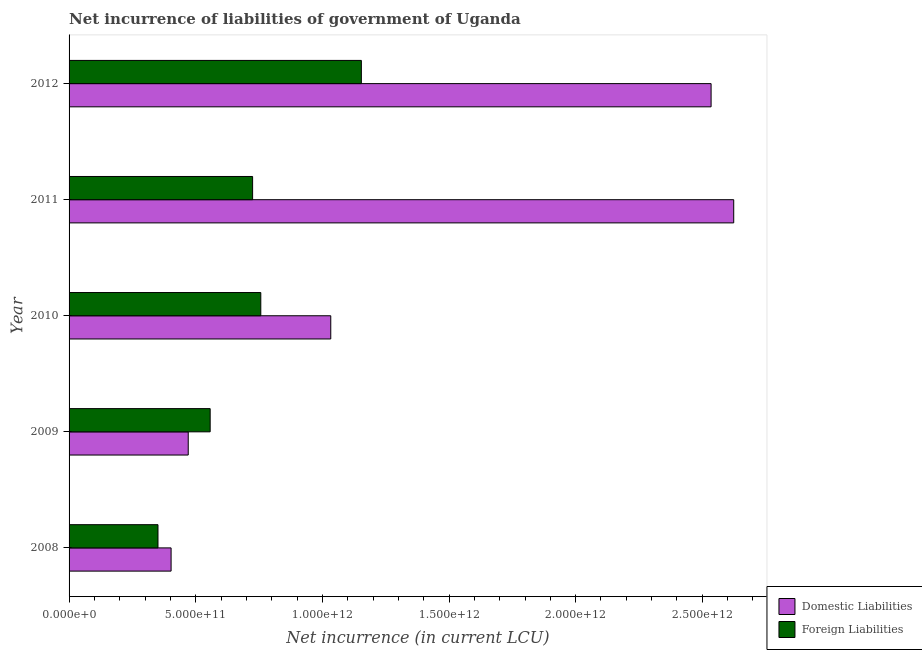How many groups of bars are there?
Offer a very short reply. 5. How many bars are there on the 5th tick from the bottom?
Offer a terse response. 2. What is the net incurrence of foreign liabilities in 2008?
Give a very brief answer. 3.51e+11. Across all years, what is the maximum net incurrence of foreign liabilities?
Your response must be concise. 1.15e+12. Across all years, what is the minimum net incurrence of domestic liabilities?
Provide a short and direct response. 4.03e+11. What is the total net incurrence of domestic liabilities in the graph?
Offer a very short reply. 7.07e+12. What is the difference between the net incurrence of domestic liabilities in 2009 and that in 2012?
Make the answer very short. -2.06e+12. What is the difference between the net incurrence of domestic liabilities in 2009 and the net incurrence of foreign liabilities in 2011?
Provide a succinct answer. -2.54e+11. What is the average net incurrence of foreign liabilities per year?
Your response must be concise. 7.09e+11. In the year 2012, what is the difference between the net incurrence of domestic liabilities and net incurrence of foreign liabilities?
Offer a very short reply. 1.38e+12. In how many years, is the net incurrence of foreign liabilities greater than 900000000000 LCU?
Your response must be concise. 1. What is the ratio of the net incurrence of foreign liabilities in 2011 to that in 2012?
Offer a terse response. 0.63. Is the difference between the net incurrence of domestic liabilities in 2008 and 2012 greater than the difference between the net incurrence of foreign liabilities in 2008 and 2012?
Ensure brevity in your answer.  No. What is the difference between the highest and the second highest net incurrence of foreign liabilities?
Ensure brevity in your answer.  3.97e+11. What is the difference between the highest and the lowest net incurrence of foreign liabilities?
Your answer should be compact. 8.03e+11. Is the sum of the net incurrence of domestic liabilities in 2009 and 2010 greater than the maximum net incurrence of foreign liabilities across all years?
Provide a short and direct response. Yes. What does the 2nd bar from the top in 2011 represents?
Ensure brevity in your answer.  Domestic Liabilities. What does the 1st bar from the bottom in 2011 represents?
Offer a very short reply. Domestic Liabilities. How many bars are there?
Your response must be concise. 10. What is the difference between two consecutive major ticks on the X-axis?
Give a very brief answer. 5.00e+11. Are the values on the major ticks of X-axis written in scientific E-notation?
Give a very brief answer. Yes. Does the graph contain any zero values?
Offer a terse response. No. Where does the legend appear in the graph?
Your response must be concise. Bottom right. What is the title of the graph?
Make the answer very short. Net incurrence of liabilities of government of Uganda. What is the label or title of the X-axis?
Your answer should be very brief. Net incurrence (in current LCU). What is the label or title of the Y-axis?
Provide a succinct answer. Year. What is the Net incurrence (in current LCU) in Domestic Liabilities in 2008?
Offer a terse response. 4.03e+11. What is the Net incurrence (in current LCU) in Foreign Liabilities in 2008?
Your response must be concise. 3.51e+11. What is the Net incurrence (in current LCU) of Domestic Liabilities in 2009?
Your response must be concise. 4.70e+11. What is the Net incurrence (in current LCU) in Foreign Liabilities in 2009?
Offer a very short reply. 5.57e+11. What is the Net incurrence (in current LCU) in Domestic Liabilities in 2010?
Offer a very short reply. 1.03e+12. What is the Net incurrence (in current LCU) of Foreign Liabilities in 2010?
Provide a succinct answer. 7.57e+11. What is the Net incurrence (in current LCU) in Domestic Liabilities in 2011?
Your response must be concise. 2.62e+12. What is the Net incurrence (in current LCU) in Foreign Liabilities in 2011?
Give a very brief answer. 7.25e+11. What is the Net incurrence (in current LCU) of Domestic Liabilities in 2012?
Keep it short and to the point. 2.53e+12. What is the Net incurrence (in current LCU) in Foreign Liabilities in 2012?
Make the answer very short. 1.15e+12. Across all years, what is the maximum Net incurrence (in current LCU) in Domestic Liabilities?
Your answer should be very brief. 2.62e+12. Across all years, what is the maximum Net incurrence (in current LCU) in Foreign Liabilities?
Your answer should be compact. 1.15e+12. Across all years, what is the minimum Net incurrence (in current LCU) of Domestic Liabilities?
Your answer should be compact. 4.03e+11. Across all years, what is the minimum Net incurrence (in current LCU) in Foreign Liabilities?
Provide a short and direct response. 3.51e+11. What is the total Net incurrence (in current LCU) of Domestic Liabilities in the graph?
Make the answer very short. 7.07e+12. What is the total Net incurrence (in current LCU) of Foreign Liabilities in the graph?
Offer a terse response. 3.54e+12. What is the difference between the Net incurrence (in current LCU) of Domestic Liabilities in 2008 and that in 2009?
Keep it short and to the point. -6.77e+1. What is the difference between the Net incurrence (in current LCU) in Foreign Liabilities in 2008 and that in 2009?
Offer a very short reply. -2.06e+11. What is the difference between the Net incurrence (in current LCU) in Domestic Liabilities in 2008 and that in 2010?
Provide a short and direct response. -6.30e+11. What is the difference between the Net incurrence (in current LCU) in Foreign Liabilities in 2008 and that in 2010?
Provide a short and direct response. -4.06e+11. What is the difference between the Net incurrence (in current LCU) in Domestic Liabilities in 2008 and that in 2011?
Provide a short and direct response. -2.22e+12. What is the difference between the Net incurrence (in current LCU) in Foreign Liabilities in 2008 and that in 2011?
Ensure brevity in your answer.  -3.74e+11. What is the difference between the Net incurrence (in current LCU) in Domestic Liabilities in 2008 and that in 2012?
Provide a short and direct response. -2.13e+12. What is the difference between the Net incurrence (in current LCU) of Foreign Liabilities in 2008 and that in 2012?
Keep it short and to the point. -8.03e+11. What is the difference between the Net incurrence (in current LCU) in Domestic Liabilities in 2009 and that in 2010?
Your response must be concise. -5.63e+11. What is the difference between the Net incurrence (in current LCU) of Foreign Liabilities in 2009 and that in 2010?
Ensure brevity in your answer.  -2.00e+11. What is the difference between the Net incurrence (in current LCU) in Domestic Liabilities in 2009 and that in 2011?
Provide a succinct answer. -2.15e+12. What is the difference between the Net incurrence (in current LCU) of Foreign Liabilities in 2009 and that in 2011?
Offer a terse response. -1.68e+11. What is the difference between the Net incurrence (in current LCU) in Domestic Liabilities in 2009 and that in 2012?
Ensure brevity in your answer.  -2.06e+12. What is the difference between the Net incurrence (in current LCU) in Foreign Liabilities in 2009 and that in 2012?
Your answer should be very brief. -5.97e+11. What is the difference between the Net incurrence (in current LCU) in Domestic Liabilities in 2010 and that in 2011?
Your answer should be very brief. -1.59e+12. What is the difference between the Net incurrence (in current LCU) of Foreign Liabilities in 2010 and that in 2011?
Ensure brevity in your answer.  3.24e+1. What is the difference between the Net incurrence (in current LCU) in Domestic Liabilities in 2010 and that in 2012?
Your answer should be very brief. -1.50e+12. What is the difference between the Net incurrence (in current LCU) in Foreign Liabilities in 2010 and that in 2012?
Provide a short and direct response. -3.97e+11. What is the difference between the Net incurrence (in current LCU) of Domestic Liabilities in 2011 and that in 2012?
Provide a succinct answer. 8.93e+1. What is the difference between the Net incurrence (in current LCU) in Foreign Liabilities in 2011 and that in 2012?
Give a very brief answer. -4.29e+11. What is the difference between the Net incurrence (in current LCU) of Domestic Liabilities in 2008 and the Net incurrence (in current LCU) of Foreign Liabilities in 2009?
Make the answer very short. -1.54e+11. What is the difference between the Net incurrence (in current LCU) of Domestic Liabilities in 2008 and the Net incurrence (in current LCU) of Foreign Liabilities in 2010?
Offer a terse response. -3.54e+11. What is the difference between the Net incurrence (in current LCU) in Domestic Liabilities in 2008 and the Net incurrence (in current LCU) in Foreign Liabilities in 2011?
Ensure brevity in your answer.  -3.22e+11. What is the difference between the Net incurrence (in current LCU) of Domestic Liabilities in 2008 and the Net incurrence (in current LCU) of Foreign Liabilities in 2012?
Provide a short and direct response. -7.51e+11. What is the difference between the Net incurrence (in current LCU) in Domestic Liabilities in 2009 and the Net incurrence (in current LCU) in Foreign Liabilities in 2010?
Your answer should be very brief. -2.86e+11. What is the difference between the Net incurrence (in current LCU) in Domestic Liabilities in 2009 and the Net incurrence (in current LCU) in Foreign Liabilities in 2011?
Your answer should be very brief. -2.54e+11. What is the difference between the Net incurrence (in current LCU) in Domestic Liabilities in 2009 and the Net incurrence (in current LCU) in Foreign Liabilities in 2012?
Make the answer very short. -6.83e+11. What is the difference between the Net incurrence (in current LCU) of Domestic Liabilities in 2010 and the Net incurrence (in current LCU) of Foreign Liabilities in 2011?
Your answer should be compact. 3.09e+11. What is the difference between the Net incurrence (in current LCU) in Domestic Liabilities in 2010 and the Net incurrence (in current LCU) in Foreign Liabilities in 2012?
Offer a terse response. -1.21e+11. What is the difference between the Net incurrence (in current LCU) in Domestic Liabilities in 2011 and the Net incurrence (in current LCU) in Foreign Liabilities in 2012?
Offer a terse response. 1.47e+12. What is the average Net incurrence (in current LCU) in Domestic Liabilities per year?
Make the answer very short. 1.41e+12. What is the average Net incurrence (in current LCU) in Foreign Liabilities per year?
Give a very brief answer. 7.09e+11. In the year 2008, what is the difference between the Net incurrence (in current LCU) of Domestic Liabilities and Net incurrence (in current LCU) of Foreign Liabilities?
Make the answer very short. 5.17e+1. In the year 2009, what is the difference between the Net incurrence (in current LCU) of Domestic Liabilities and Net incurrence (in current LCU) of Foreign Liabilities?
Your response must be concise. -8.66e+1. In the year 2010, what is the difference between the Net incurrence (in current LCU) of Domestic Liabilities and Net incurrence (in current LCU) of Foreign Liabilities?
Make the answer very short. 2.76e+11. In the year 2011, what is the difference between the Net incurrence (in current LCU) of Domestic Liabilities and Net incurrence (in current LCU) of Foreign Liabilities?
Your response must be concise. 1.90e+12. In the year 2012, what is the difference between the Net incurrence (in current LCU) of Domestic Liabilities and Net incurrence (in current LCU) of Foreign Liabilities?
Your response must be concise. 1.38e+12. What is the ratio of the Net incurrence (in current LCU) of Domestic Liabilities in 2008 to that in 2009?
Your response must be concise. 0.86. What is the ratio of the Net incurrence (in current LCU) in Foreign Liabilities in 2008 to that in 2009?
Provide a succinct answer. 0.63. What is the ratio of the Net incurrence (in current LCU) of Domestic Liabilities in 2008 to that in 2010?
Keep it short and to the point. 0.39. What is the ratio of the Net incurrence (in current LCU) of Foreign Liabilities in 2008 to that in 2010?
Provide a succinct answer. 0.46. What is the ratio of the Net incurrence (in current LCU) in Domestic Liabilities in 2008 to that in 2011?
Offer a very short reply. 0.15. What is the ratio of the Net incurrence (in current LCU) in Foreign Liabilities in 2008 to that in 2011?
Keep it short and to the point. 0.48. What is the ratio of the Net incurrence (in current LCU) of Domestic Liabilities in 2008 to that in 2012?
Make the answer very short. 0.16. What is the ratio of the Net incurrence (in current LCU) in Foreign Liabilities in 2008 to that in 2012?
Ensure brevity in your answer.  0.3. What is the ratio of the Net incurrence (in current LCU) in Domestic Liabilities in 2009 to that in 2010?
Your response must be concise. 0.46. What is the ratio of the Net incurrence (in current LCU) of Foreign Liabilities in 2009 to that in 2010?
Make the answer very short. 0.74. What is the ratio of the Net incurrence (in current LCU) of Domestic Liabilities in 2009 to that in 2011?
Offer a very short reply. 0.18. What is the ratio of the Net incurrence (in current LCU) of Foreign Liabilities in 2009 to that in 2011?
Offer a very short reply. 0.77. What is the ratio of the Net incurrence (in current LCU) of Domestic Liabilities in 2009 to that in 2012?
Offer a very short reply. 0.19. What is the ratio of the Net incurrence (in current LCU) of Foreign Liabilities in 2009 to that in 2012?
Give a very brief answer. 0.48. What is the ratio of the Net incurrence (in current LCU) of Domestic Liabilities in 2010 to that in 2011?
Ensure brevity in your answer.  0.39. What is the ratio of the Net incurrence (in current LCU) of Foreign Liabilities in 2010 to that in 2011?
Offer a very short reply. 1.04. What is the ratio of the Net incurrence (in current LCU) of Domestic Liabilities in 2010 to that in 2012?
Your answer should be compact. 0.41. What is the ratio of the Net incurrence (in current LCU) of Foreign Liabilities in 2010 to that in 2012?
Your response must be concise. 0.66. What is the ratio of the Net incurrence (in current LCU) in Domestic Liabilities in 2011 to that in 2012?
Ensure brevity in your answer.  1.04. What is the ratio of the Net incurrence (in current LCU) in Foreign Liabilities in 2011 to that in 2012?
Ensure brevity in your answer.  0.63. What is the difference between the highest and the second highest Net incurrence (in current LCU) in Domestic Liabilities?
Provide a short and direct response. 8.93e+1. What is the difference between the highest and the second highest Net incurrence (in current LCU) of Foreign Liabilities?
Provide a short and direct response. 3.97e+11. What is the difference between the highest and the lowest Net incurrence (in current LCU) in Domestic Liabilities?
Your answer should be very brief. 2.22e+12. What is the difference between the highest and the lowest Net incurrence (in current LCU) in Foreign Liabilities?
Offer a terse response. 8.03e+11. 